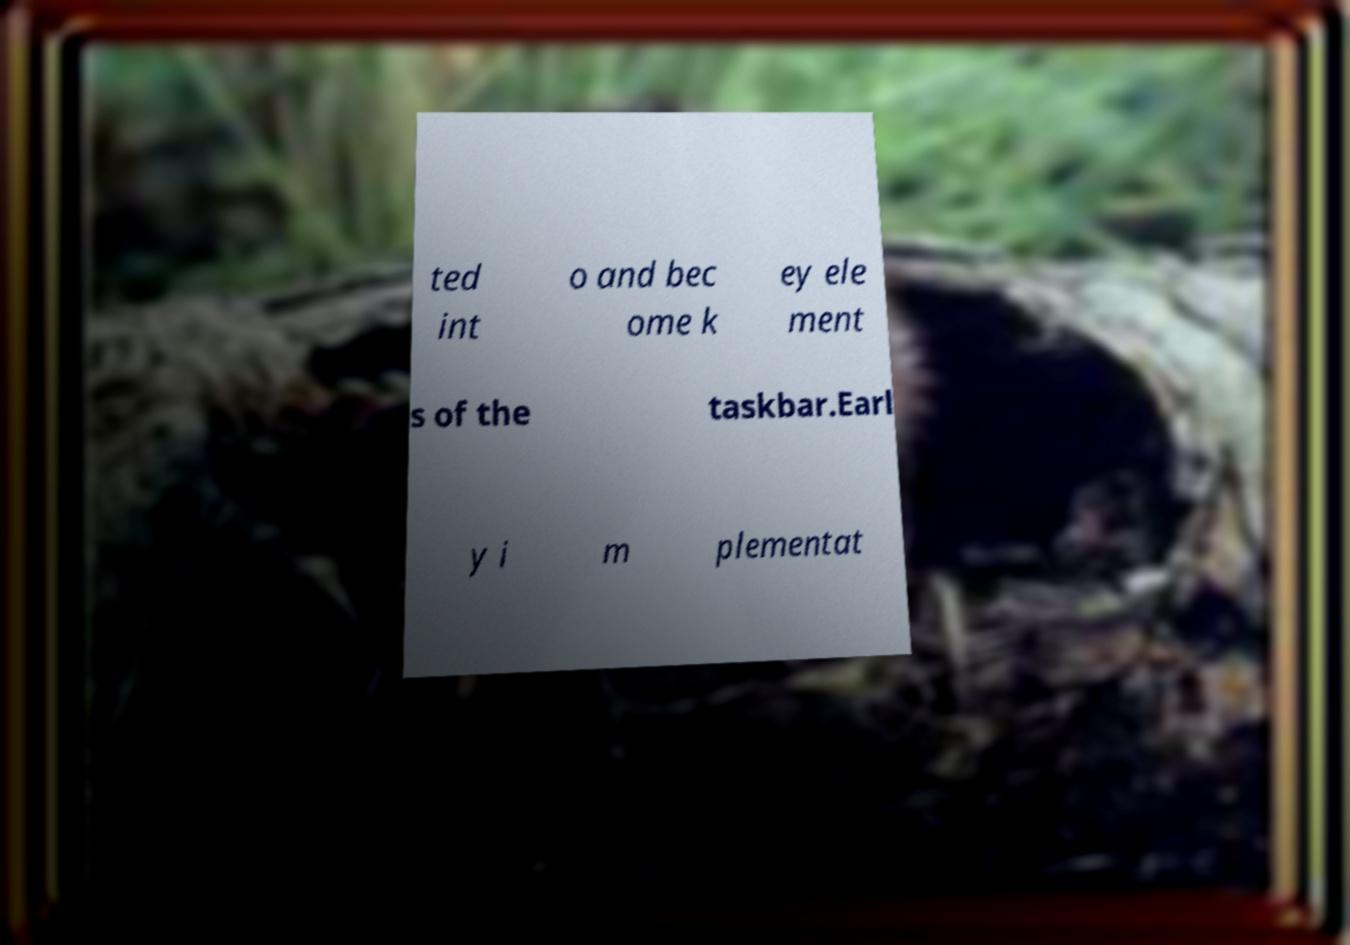Could you extract and type out the text from this image? ted int o and bec ome k ey ele ment s of the taskbar.Earl y i m plementat 